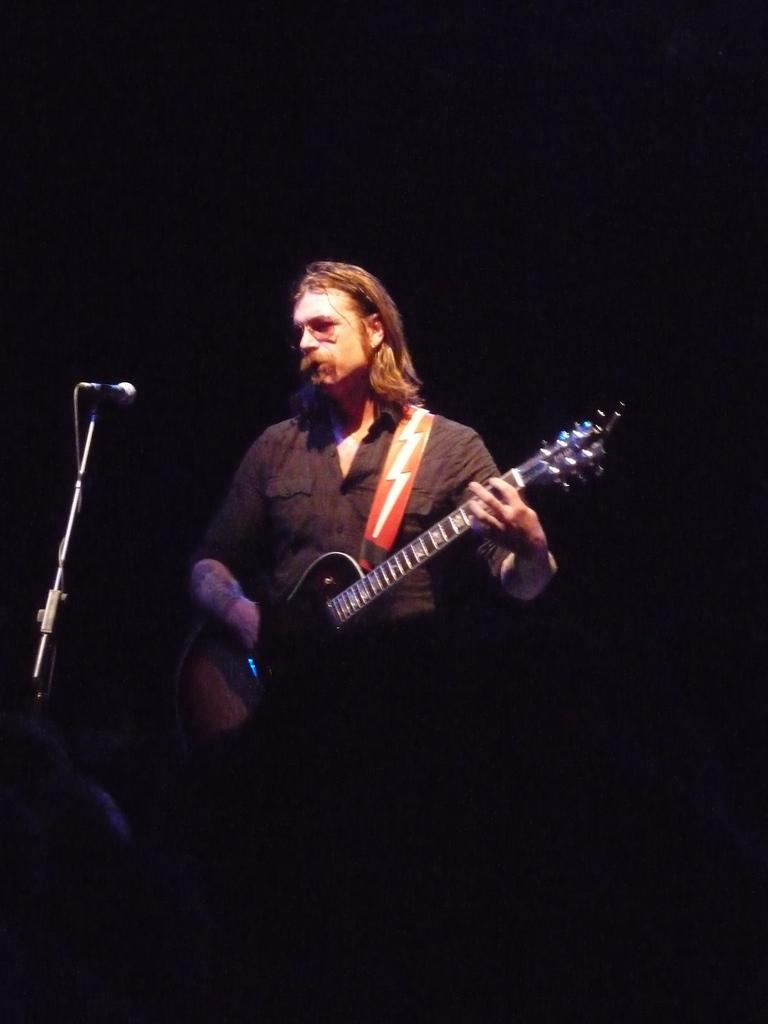What is the main subject of the image? There is a person standing in the center of the image. What is the person holding in the image? The person is holding a guitar. What object is located on the left side of the image? There is a microphone on the left side of the image. Where is the desk located in the image? There is no desk present in the image. What type of furniture can be seen in the bedroom in the image? There is no bedroom or furniture present in the image. 